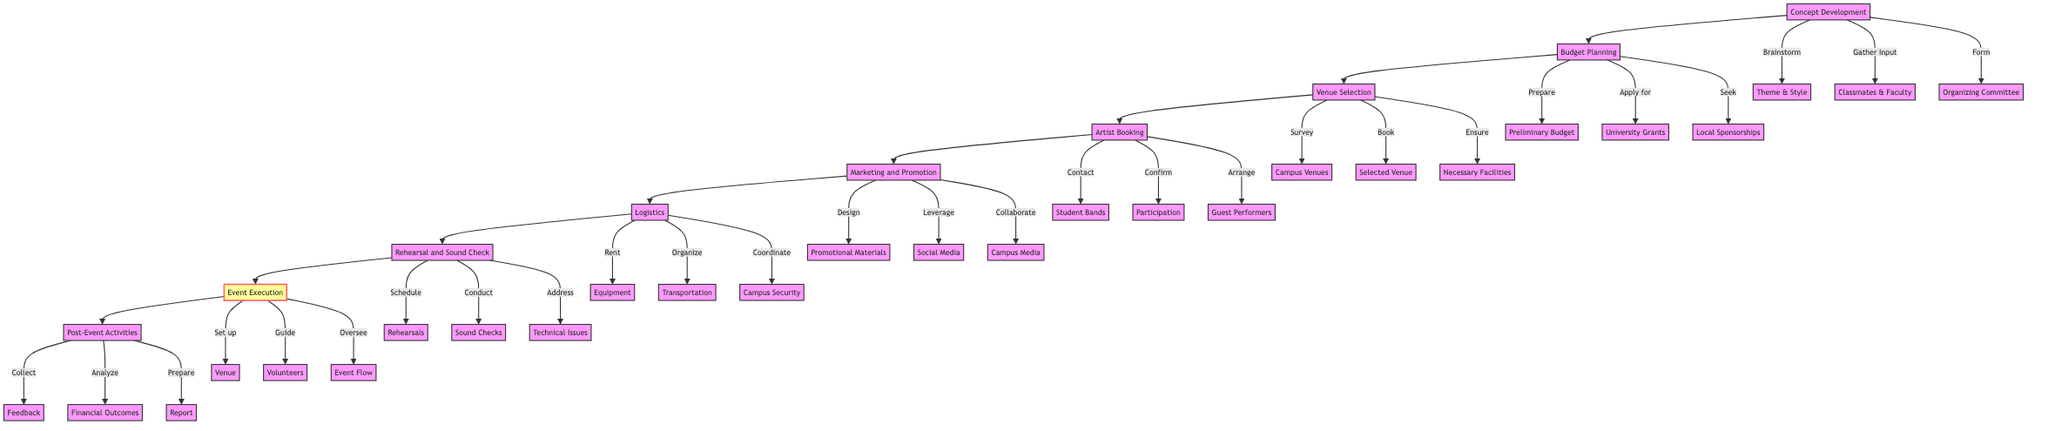What is the first step in organizing a campus music event? The diagram shows that the first step is "Concept Development," which involves brainstorming the theme and style of the event.
Answer: Concept Development How many major phases are there in the event organization process? The flowchart outlines a total of 8 major phases from "Concept Development" to "Post-Event Activities."
Answer: 8 What task is associated with Budget Planning? One task within Budget Planning is to "Prepare a preliminary budget," indicating that budgeting is a foundational step in this phase.
Answer: Prepare a preliminary budget Which phase follows Venue Selection? The diagram indicates that "Artist Booking" directly follows "Venue Selection," signifying the order of planning actions.
Answer: Artist Booking What is a subgroup task under Marketing and Promotion? One task listed under Marketing and Promotion is to "Design promotional materials," indicating actions aimed at promoting the event.
Answer: Design promotional materials What does the Event Execution phase involve? The Event Execution phase involves several actions, including "Set up the venue" and "Oversee the flow of the event," indicating the responsibilities during the event.
Answer: Set up the venue What is required after the Event Execution phase? After Event Execution, the next phase is "Post-Event Activities," which entails wrapping up and evaluating everything that occurred during the event.
Answer: Post-Event Activities In which phase is feedback collected? Feedback is collected during the "Post-Event Activities" phase, highlighting an essential step for evaluating the success of the event.
Answer: Post-Event Activities What is the last task listed in the flowchart? The last task listed is "Prepare a report for future reference," found in the Post-Event Activities phase, suggesting a continuous improvement approach.
Answer: Prepare a report for future reference 